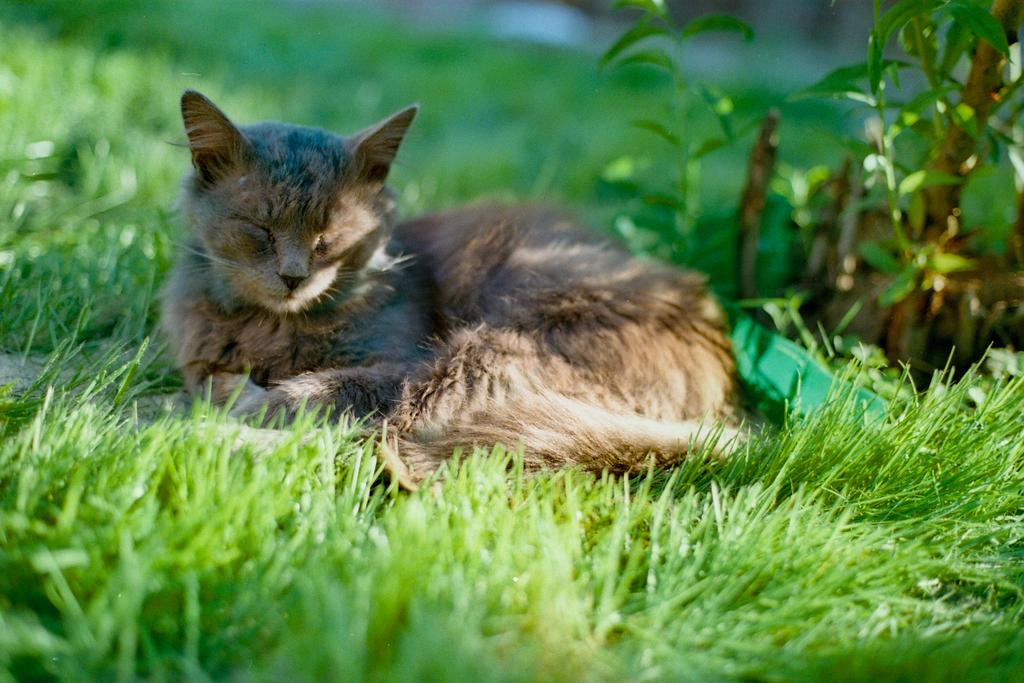What type of surface is visible on the ground in the image? There is grass on the ground in the image. What animal can be seen laying in the image? There is a cat laying in the middle of the image. What type of vegetation is present on the right side of the image? There are plants on the right side of the image. How does the cat adjust its glasses in the image? The cat does not have glasses, and therefore there is no adjustment to be made in the image. 